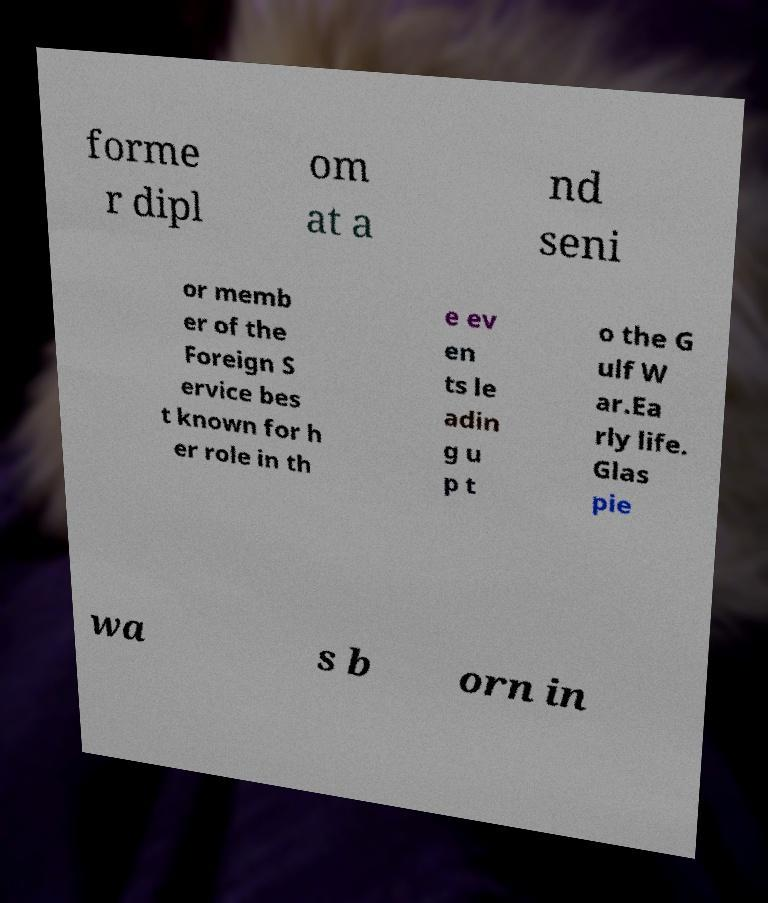Can you read and provide the text displayed in the image?This photo seems to have some interesting text. Can you extract and type it out for me? forme r dipl om at a nd seni or memb er of the Foreign S ervice bes t known for h er role in th e ev en ts le adin g u p t o the G ulf W ar.Ea rly life. Glas pie wa s b orn in 